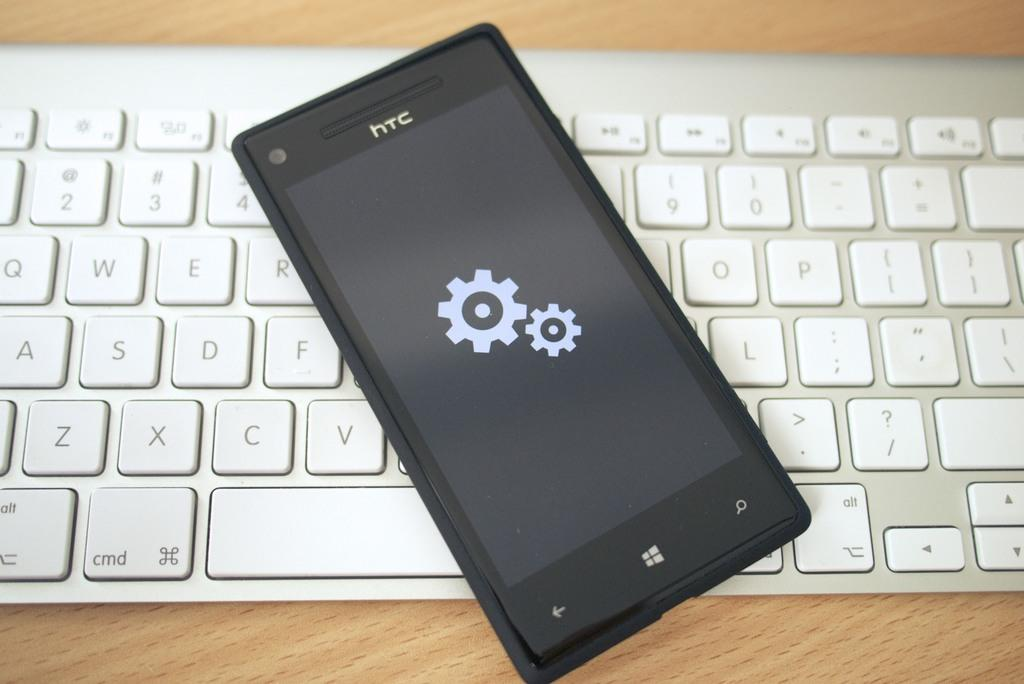<image>
Summarize the visual content of the image. A black HTC phone is lying on top of a keyboard 